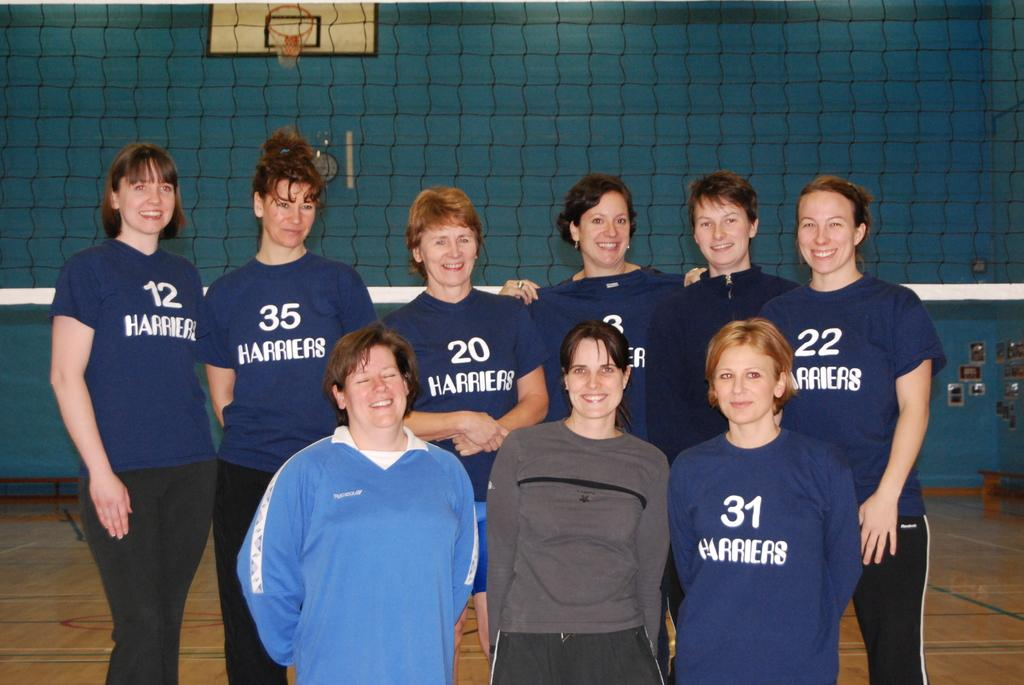Provide a one-sentence caption for the provided image. A group of women stand in front of a net wearing blue shirts that say Harriers. 